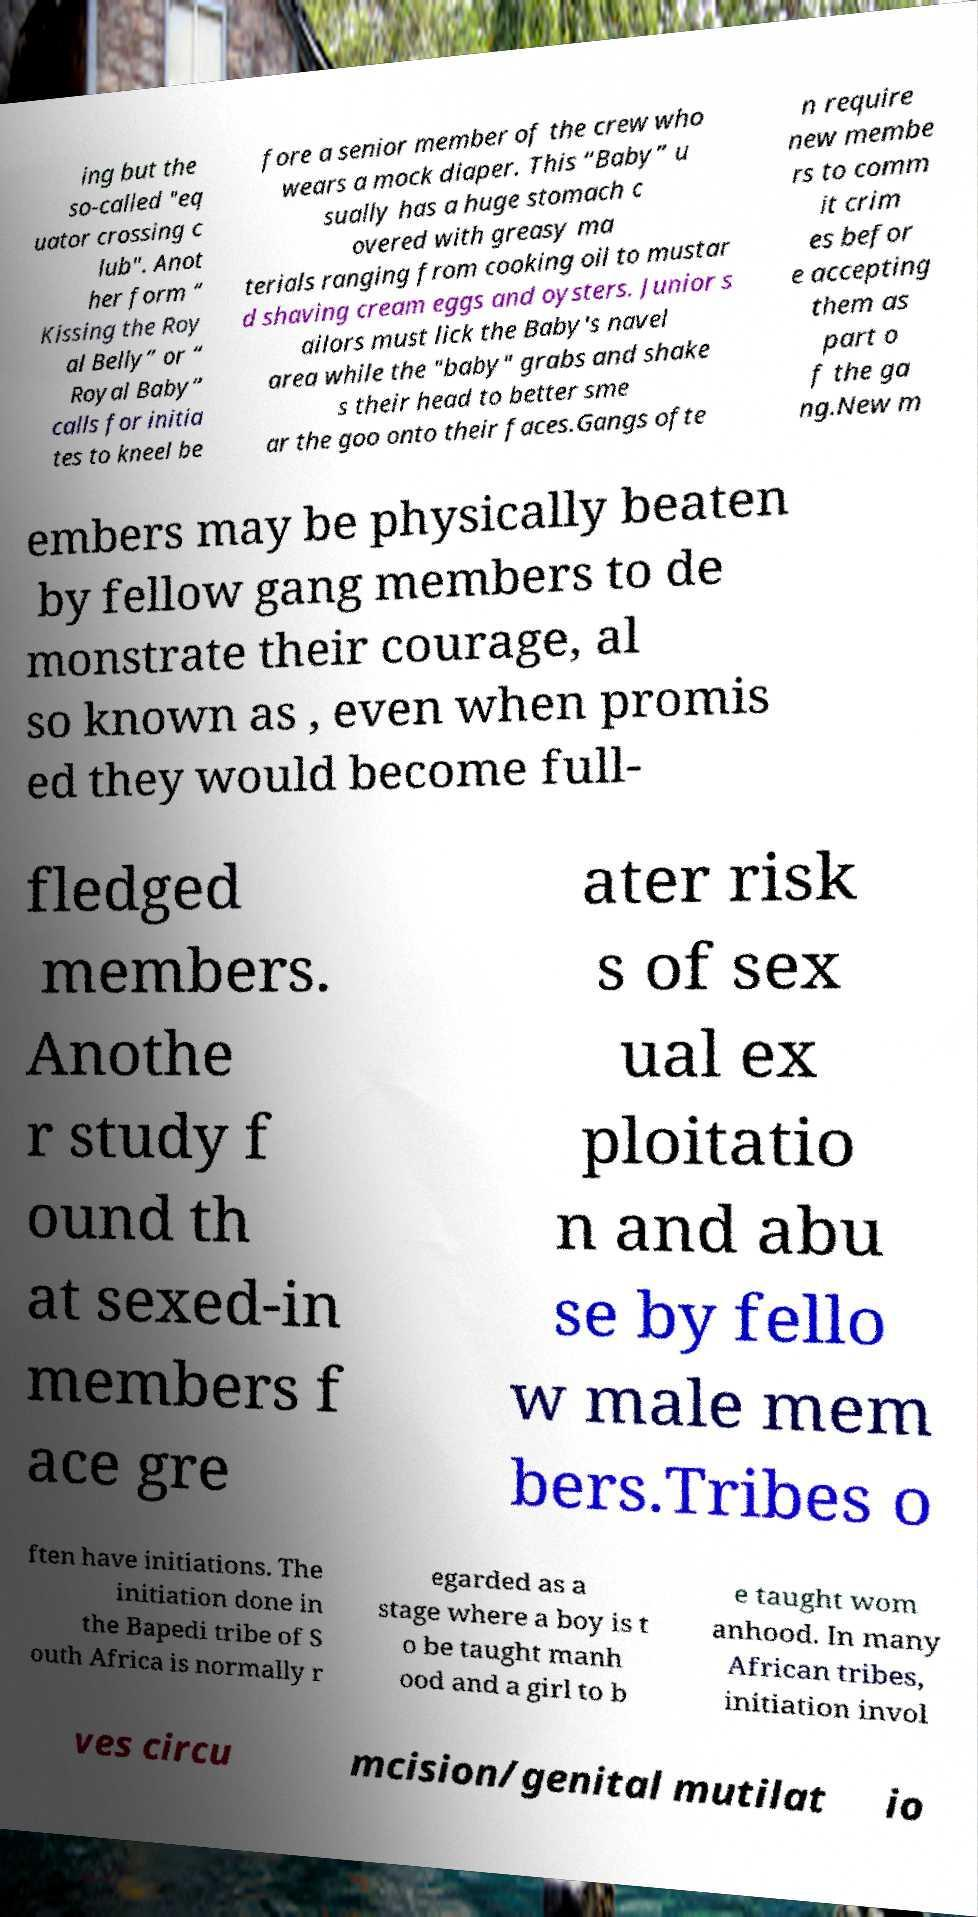Could you extract and type out the text from this image? ing but the so-called "eq uator crossing c lub". Anot her form “ Kissing the Roy al Belly” or “ Royal Baby” calls for initia tes to kneel be fore a senior member of the crew who wears a mock diaper. This “Baby” u sually has a huge stomach c overed with greasy ma terials ranging from cooking oil to mustar d shaving cream eggs and oysters. Junior s ailors must lick the Baby's navel area while the "baby" grabs and shake s their head to better sme ar the goo onto their faces.Gangs ofte n require new membe rs to comm it crim es befor e accepting them as part o f the ga ng.New m embers may be physically beaten by fellow gang members to de monstrate their courage, al so known as , even when promis ed they would become full- fledged members. Anothe r study f ound th at sexed-in members f ace gre ater risk s of sex ual ex ploitatio n and abu se by fello w male mem bers.Tribes o ften have initiations. The initiation done in the Bapedi tribe of S outh Africa is normally r egarded as a stage where a boy is t o be taught manh ood and a girl to b e taught wom anhood. In many African tribes, initiation invol ves circu mcision/genital mutilat io 